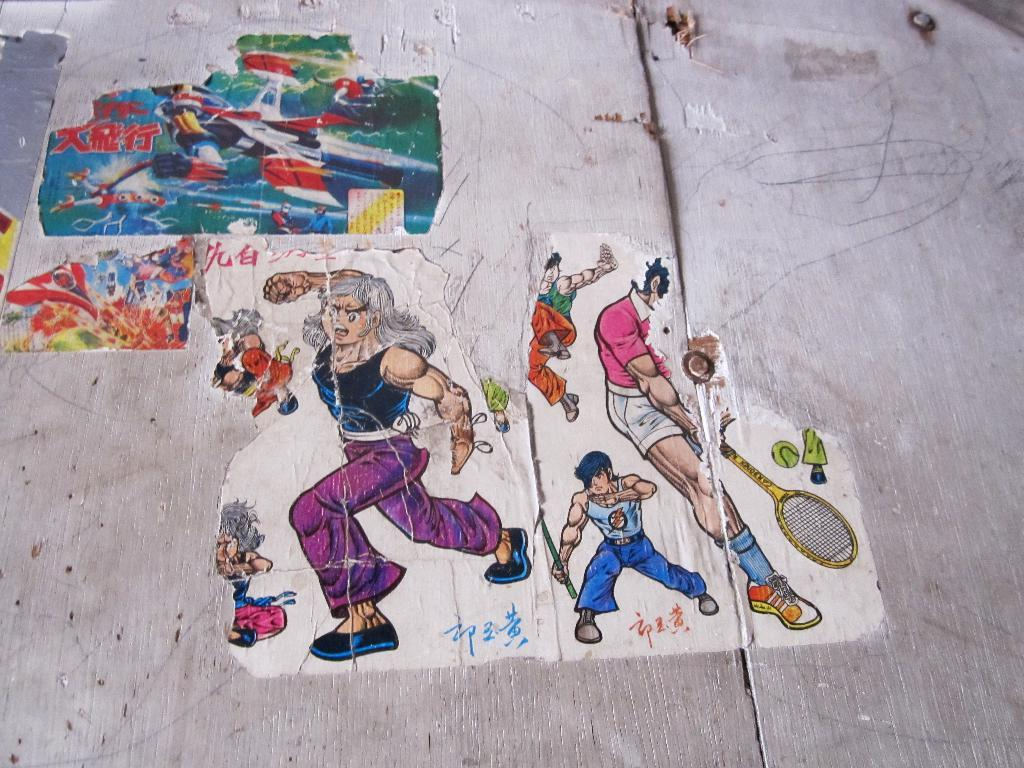What type of stickers are in the image? There are cartoon stickers in the image. Where are the stickers located? The stickers are attached to a wooden surface. Reasoning: Let' Let's think step by step in order to produce the conversation. We start by identifying the main subject in the image, which is the cartoon stickers. Then, we describe their location, which is on a wooden surface. We avoid making any assumptions about the image and focus on the facts provided. Absurd Question/Answer: Is there a maid cleaning the wooden surface with ice in the image? No, there is no maid or ice present in the image. 